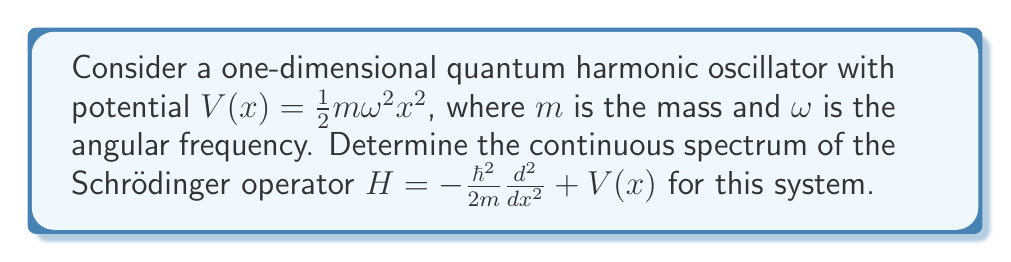Provide a solution to this math problem. To analyze the continuous spectrum of the Schrödinger operator for a quantum harmonic oscillator, we'll follow these steps:

1) The Schrödinger operator for this system is:

   $$H = -\frac{\hbar^2}{2m}\frac{d^2}{dx^2} + \frac{1}{2}m\omega^2x^2$$

2) The continuous spectrum is associated with unbounded states. For the harmonic oscillator, all eigenstates are bounded and normalizable.

3) The energy eigenvalues for the quantum harmonic oscillator are given by:

   $$E_n = \hbar\omega(n + \frac{1}{2}), \quad n = 0, 1, 2, ...$$

4) These energy levels form a discrete set, with no continuous range of values.

5) The wavefunctions for these energy levels are:

   $$\psi_n(x) = \frac{1}{\sqrt{2^n n!}}\left(\frac{m\omega}{\pi\hbar}\right)^{1/4} e^{-\frac{m\omega x^2}{2\hbar}} H_n\left(\sqrt{\frac{m\omega}{\hbar}}x\right)$$

   where $H_n$ are the Hermite polynomials.

6) These wavefunctions decay exponentially as $|x| \to \infty$, which means they are square-integrable and represent bound states.

7) For a continuous spectrum to exist, we would need non-normalizable wavefunctions that extend to infinity. However, the potential $V(x) \to \infty$ as $|x| \to \infty$, which confines all states.

8) Therefore, the Schrödinger operator for the quantum harmonic oscillator has no continuous spectrum.
Answer: The continuous spectrum of the Schrödinger operator for a quantum harmonic oscillator is empty. 